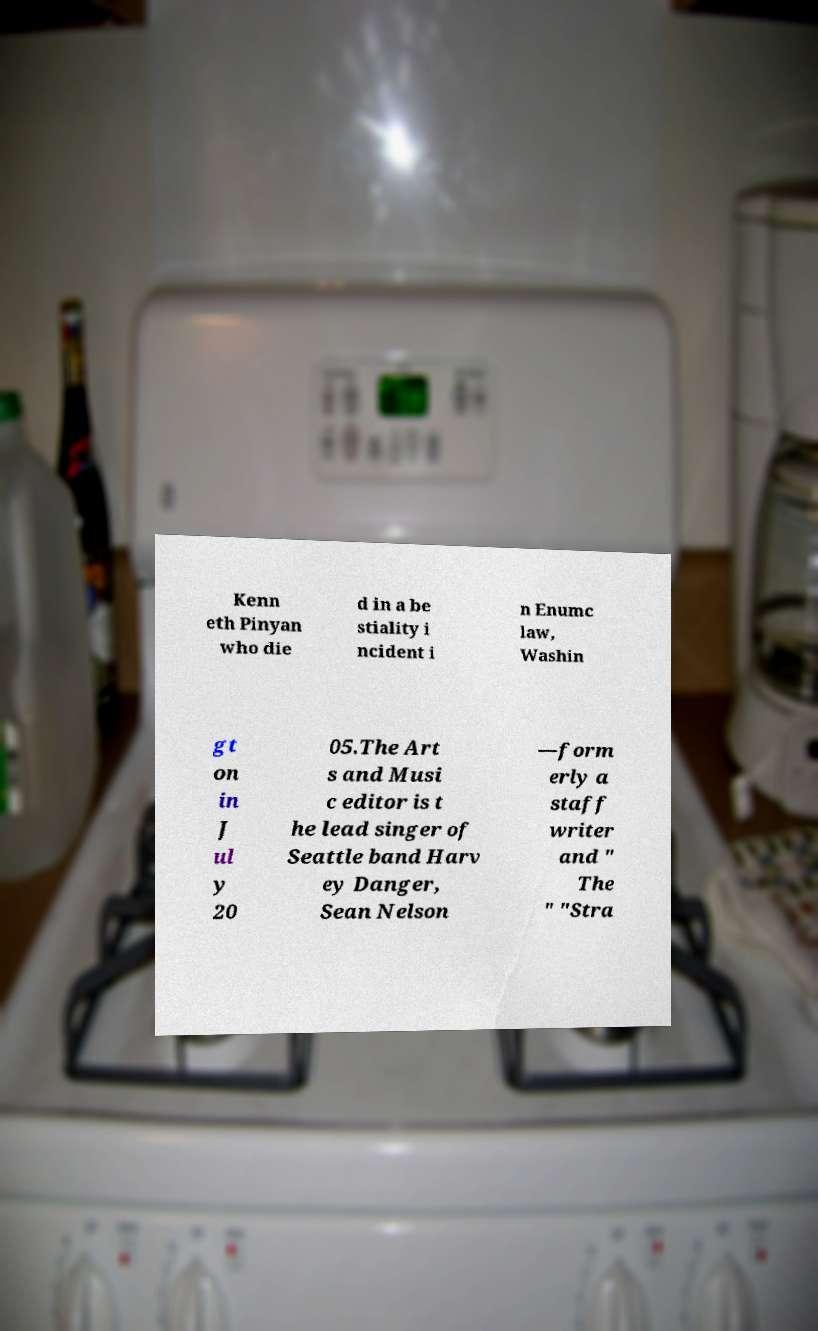Please identify and transcribe the text found in this image. Kenn eth Pinyan who die d in a be stiality i ncident i n Enumc law, Washin gt on in J ul y 20 05.The Art s and Musi c editor is t he lead singer of Seattle band Harv ey Danger, Sean Nelson —form erly a staff writer and " The " "Stra 